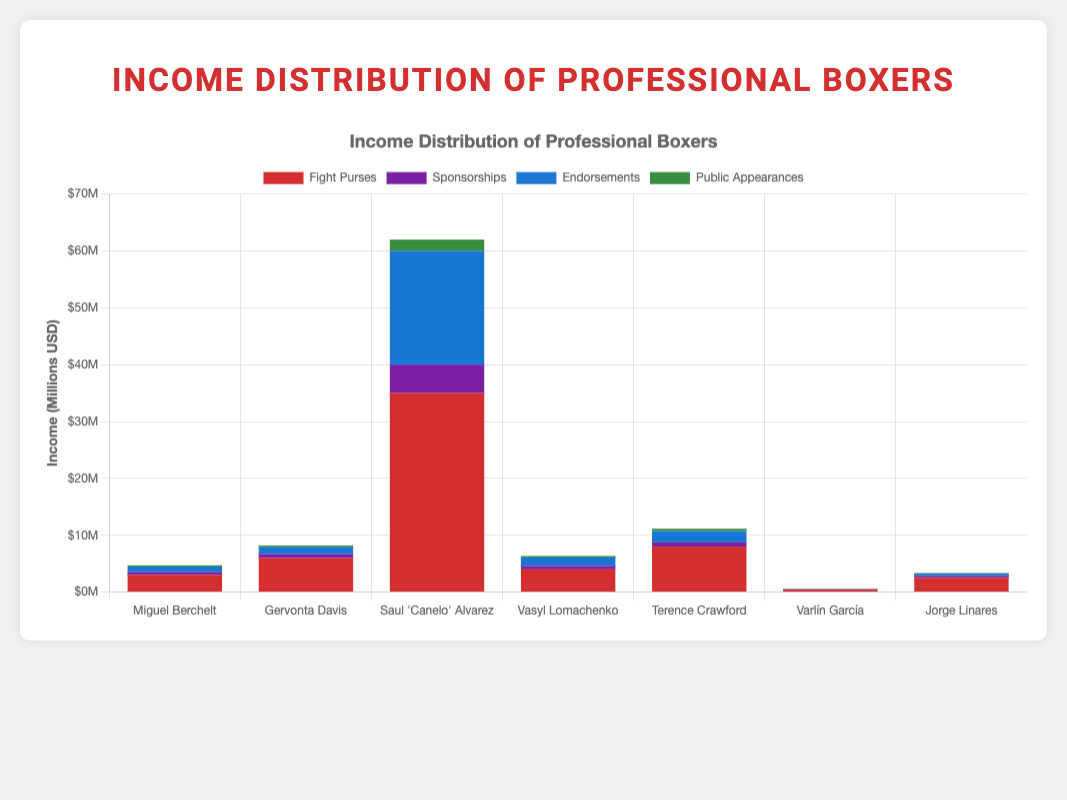Which boxer has the highest income from fight purses? By examining the lengths of the red bars, we can see that Saul 'Canelo' Alvarez has the longest red bar representing his fight purse income of $35,000,000.
Answer: Saul 'Canelo' Alvarez How much more does Terence Crawford earn from endorsements compared to Jorge Linares? The endorsement income for Terence Crawford is $2,000,000, and for Jorge Linares, it is $400,000. The difference is $2,000,000 - $400,000 = $1,600,000.
Answer: $1,600,000 What is the combined income from public appearances for all boxers from Venezuela? Varlín García's public appearance income is $30,000, and Jorge Linares's public appearance income is $100,000. The combined income is $30,000 + $100,000 = $130,000.
Answer: $130,000 Which boxer has the lowest total income and what is that amount? Varlín García’s total income comprises: fight purses $450,000 + sponsorships $50,000 + endorsements $70,000 + public appearances $30,000. The total is $600,000, which is the lowest compared to the other boxers.
Answer: Varlín García, $600,000 Among the listed income sources, which category does Miguel Berchelt earn the least from? By inspecting the heights of Miguel Berchelt’s bars, the shortest green bar represents public appearances income, which is $200,000.
Answer: Public appearances If you sum up the endorsement incomes of all boxers from Mexico, what is the total? The endorsement income for Miguel Berchelt is $1,000,000 and for Saul 'Canelo' Alvarez is $20,000,000. The total is $1,000,000 + $20,000,000 = $21,000,000.
Answer: $21,000,000 How many boxers have a higher income from sponsorships than from public appearances? By comparing the purple bars (sponsorships) to green bars (public appearances) for each boxer, all boxers have higher sponsorship incomes than public appearances. So, the count is 7.
Answer: 7 Who earns more from sponsorships: Vasyl Lomachenko or Terence Crawford? Comparing the heights of the purple bars for Vasyl Lomachenko (sponsorships $600,000) and Terence Crawford ($750,000), Terence Crawford has a higher earnings from sponsorships.
Answer: Terence Crawford What is the difference in the total income between Miguel Berchelt and Vasyl Lomachenko? Miguel Berchelt’s total income is: fight purses $3,000,000 + sponsorships $500,000 + endorsements $1,000,000 + public appearances $200,000 = $4,700,000. Vasyl Lomachenko’s total income is: fight purses $4,000,000 + sponsorships $600,000 + endorsements $1,500,000 + public appearances $250,000 = $6,350,000. The difference is $6,350,000 - $4,700,000 = $1,650,000.
Answer: $1,650,000 